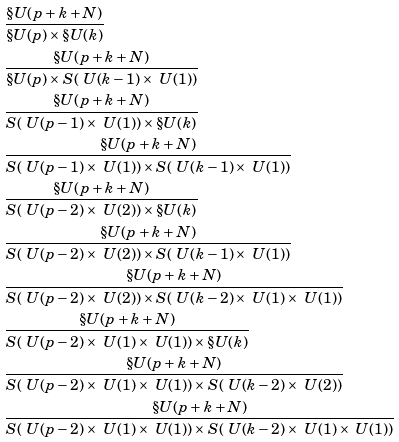Convert formula to latex. <formula><loc_0><loc_0><loc_500><loc_500>& \frac { \S U ( p + k + N ) } { \S U ( p ) \times \S U ( k ) } \\ & \frac { \S U ( p + k + N ) } { \S U ( p ) \times S ( \ U ( k - 1 ) \times \ U ( 1 ) ) } \\ & \frac { \S U ( p + k + N ) } { S ( \ U ( p - 1 ) \times \ U ( 1 ) ) \times \S U ( k ) } \\ & \frac { \S U ( p + k + N ) } { S ( \ U ( p - 1 ) \times \ U ( 1 ) ) \times S ( \ U ( k - 1 ) \times \ U ( 1 ) ) } \\ & \frac { \S U ( p + k + N ) } { S ( \ U ( p - 2 ) \times \ U ( 2 ) ) \times \S U ( k ) } \\ & \frac { \S U ( p + k + N ) } { S ( \ U ( p - 2 ) \times \ U ( 2 ) ) \times S ( \ U ( k - 1 ) \times \ U ( 1 ) ) } \\ & \frac { \S U ( p + k + N ) } { S ( \ U ( p - 2 ) \times \ U ( 2 ) ) \times S ( \ U ( k - 2 ) \times \ U ( 1 ) \times \ U ( 1 ) ) } \\ & \frac { \S U ( p + k + N ) } { S ( \ U ( p - 2 ) \times \ U ( 1 ) \times \ U ( 1 ) ) \times \S U ( k ) } \\ & \frac { \S U ( p + k + N ) } { S ( \ U ( p - 2 ) \times \ U ( 1 ) \times \ U ( 1 ) ) \times S ( \ U ( k - 2 ) \times \ U ( 2 ) ) } \\ & \frac { \S U ( p + k + N ) } { S ( \ U ( p - 2 ) \times \ U ( 1 ) \times \ U ( 1 ) ) \times S ( \ U ( k - 2 ) \times \ U ( 1 ) \times \ U ( 1 ) ) }</formula> 